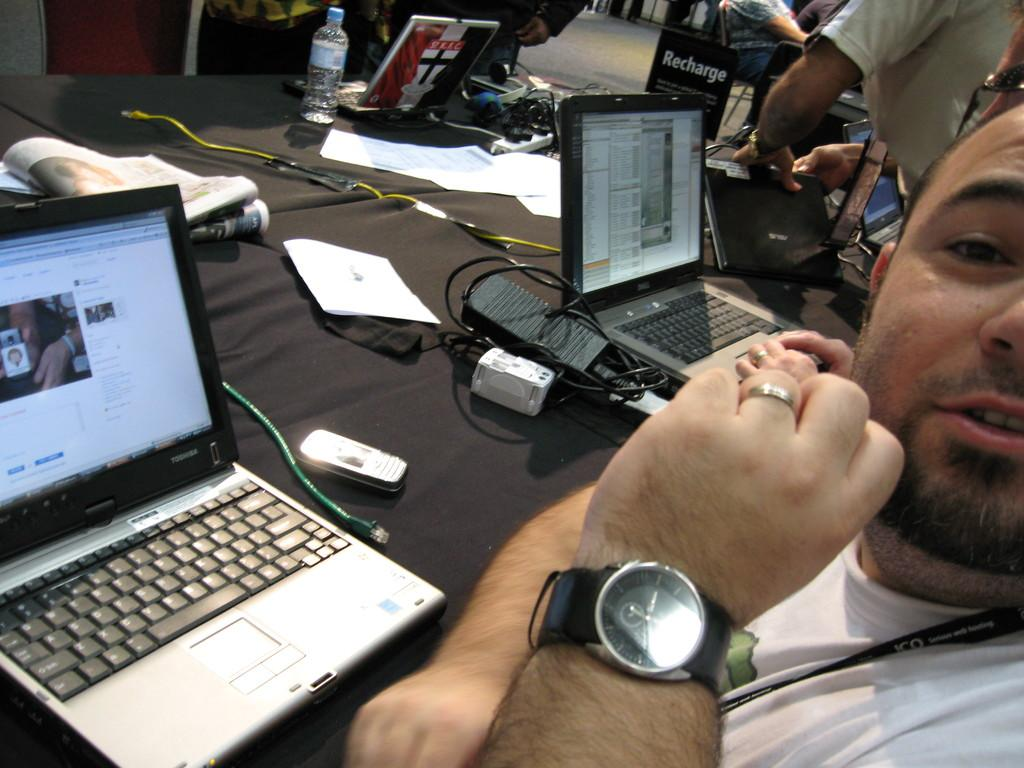Provide a one-sentence caption for the provided image. A man that is sitting in front of a computer laptop looking at the camera. 